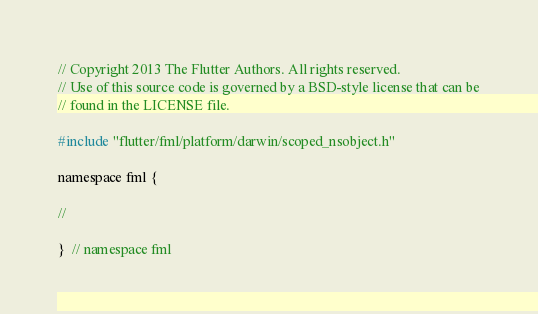<code> <loc_0><loc_0><loc_500><loc_500><_ObjectiveC_>// Copyright 2013 The Flutter Authors. All rights reserved.
// Use of this source code is governed by a BSD-style license that can be
// found in the LICENSE file.

#include "flutter/fml/platform/darwin/scoped_nsobject.h"

namespace fml {

//

}  // namespace fml
</code> 